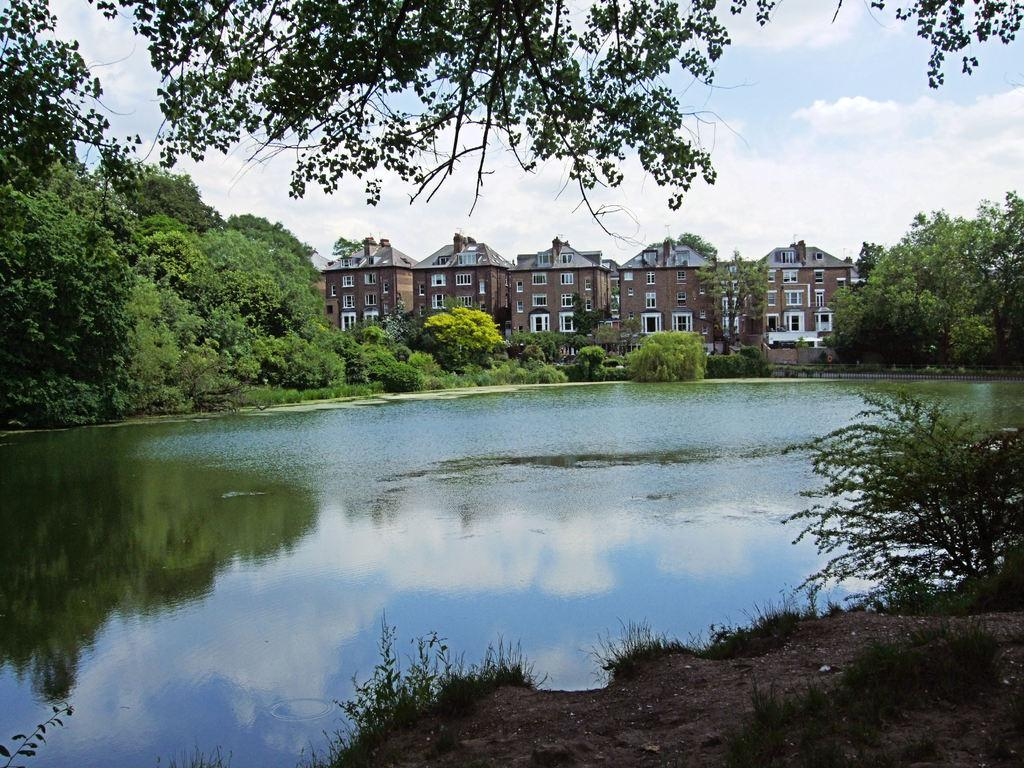What is visible in the image? Water is visible in the image. What can be seen to the right of the image? There is a plant to the right of the image. What is visible in the background of the image? There are many trees, buildings, clouds, and the sky visible in the background of the image. What type of furniture is present in the image? There is no furniture present in the image. What list can be seen in the image? There is no list visible in the image. 